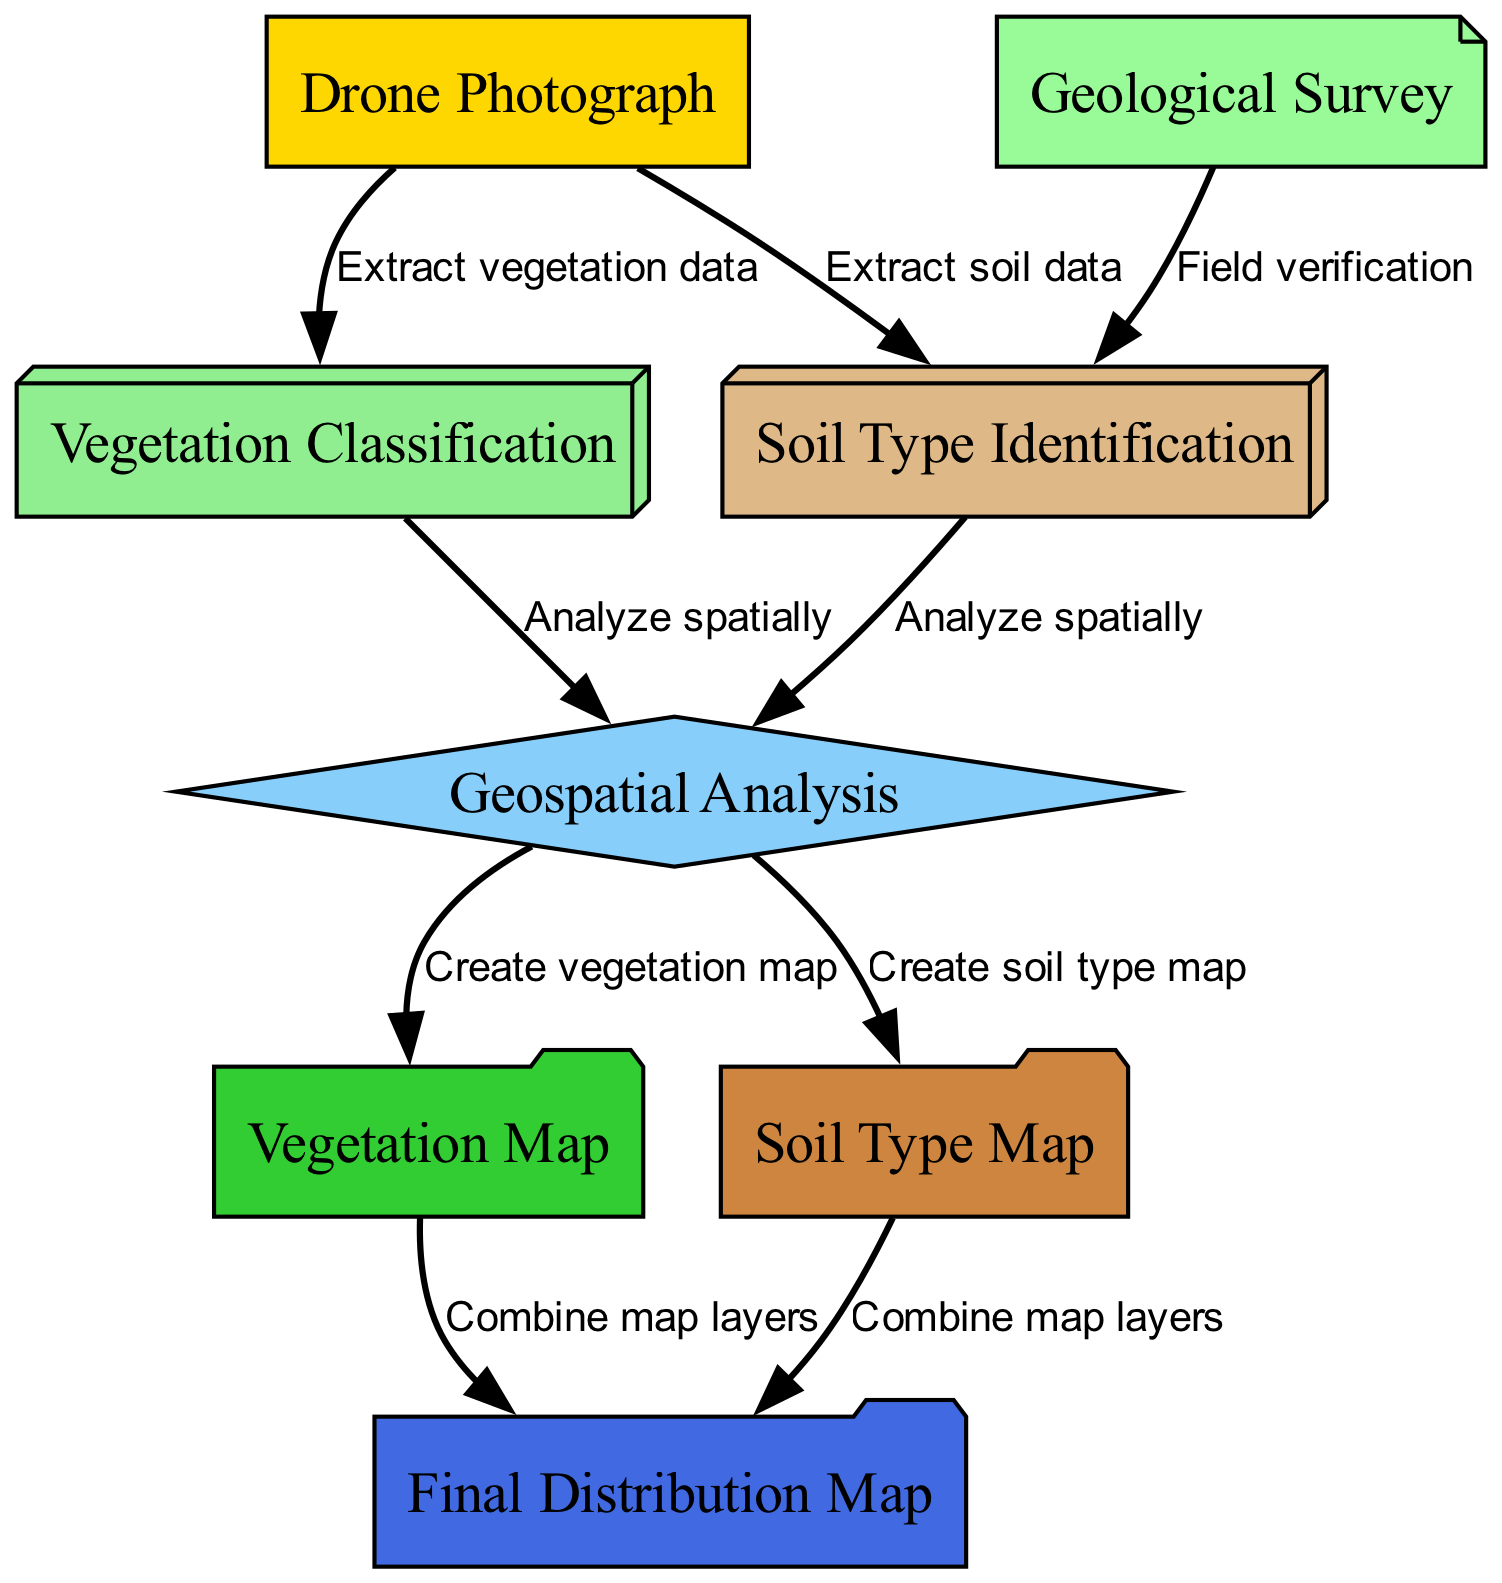What is the first node in the diagram? The first node in the diagram is identified by the node ID "1," represented as "Drone Photograph." This node serves as the entry point of the process depicted in the diagram.
Answer: Drone Photograph How many edges are in the diagram? Counting the edges displayed in the diagram reveals eight connections between the nodes. Each edge represents a relationship or flow from one node to another.
Answer: 8 Which node represents the outcome of combining map layers? The node that represents the result of combining the map layers is "Final Distribution Map." This is the final node where all analyses converge to produce a composite visualization.
Answer: Final Distribution Map What type of analysis is performed after extracting soil data? After extracting soil data, the process moves to "Geospatial Analysis," where both vegetation and soil data are analyzed spatially to create maps.
Answer: Geospatial Analysis Which two nodes must be combined to create the final distribution map? To produce the "Final Distribution Map," both the "Vegetation Map" and "Soil Type Map" need to be combined, as indicated by the edges leading to the final node.
Answer: Vegetation Map and Soil Type Map What is the relationship between "Geological Survey" and "Soil Type Identification"? The relationship indicates that the "Geological Survey" provides field verification for the soil type identification process, ensuring that the data collected is accurate and precise.
Answer: Field verification How does vegetation data contribute to the map creation? The "Vegetation Classification" node, derived from the "Drone Photograph," feeds into the "Geospatial Analysis," which is essential for creating the vegetation map as well as understanding spatial distributions.
Answer: Create vegetation map What is the purpose of the node labeled "Soil Type Identification"? The "Soil Type Identification" node's purpose is to determine the various soil categories, which is essential for understanding the environmental context of the area being studied.
Answer: Determine soil categories 